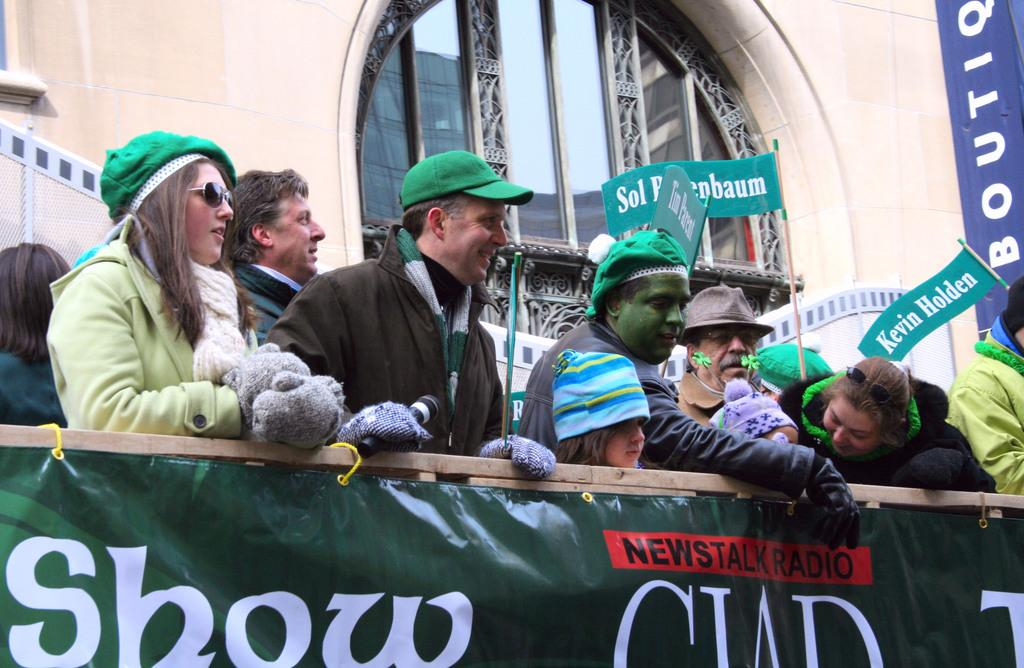Who or what is present in the image? There are people in the image. What are the people wearing on their heads? The people are wearing green caps. What else can be seen in the image besides the people? There is a banner in the image. What is visible in the background of the image? There is a building in the background of the image. What type of tin can be seen in the image? There is no tin present in the image. Is there any snow visible in the image? There is no snow visible in the image. 